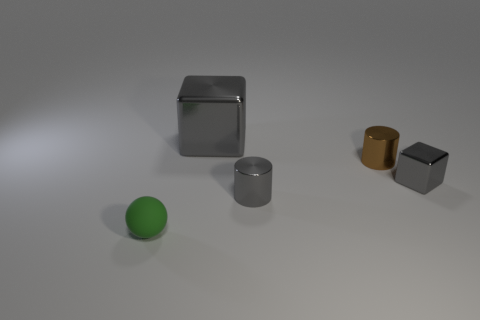Is there any other thing that has the same material as the green thing?
Offer a very short reply. No. There is a big object; does it have the same color as the cube in front of the tiny brown object?
Your answer should be very brief. Yes. What number of small gray shiny things are on the right side of the small gray metal object that is in front of the gray metallic cube that is on the right side of the large gray metallic object?
Give a very brief answer. 1. There is a big block; are there any small gray metallic blocks behind it?
Your answer should be very brief. No. Is there anything else that has the same color as the rubber ball?
Offer a very short reply. No. What number of blocks are either brown things or red objects?
Offer a very short reply. 0. How many objects are both in front of the brown shiny cylinder and to the left of the small gray cylinder?
Offer a very short reply. 1. Are there an equal number of small green rubber objects on the left side of the small green rubber object and brown shiny things behind the tiny brown cylinder?
Offer a terse response. Yes. There is a tiny gray metallic object that is to the left of the brown shiny object; does it have the same shape as the big gray object?
Your response must be concise. No. There is a gray object that is in front of the metal cube that is to the right of the large gray metal thing that is to the left of the gray metal cylinder; what shape is it?
Make the answer very short. Cylinder. 